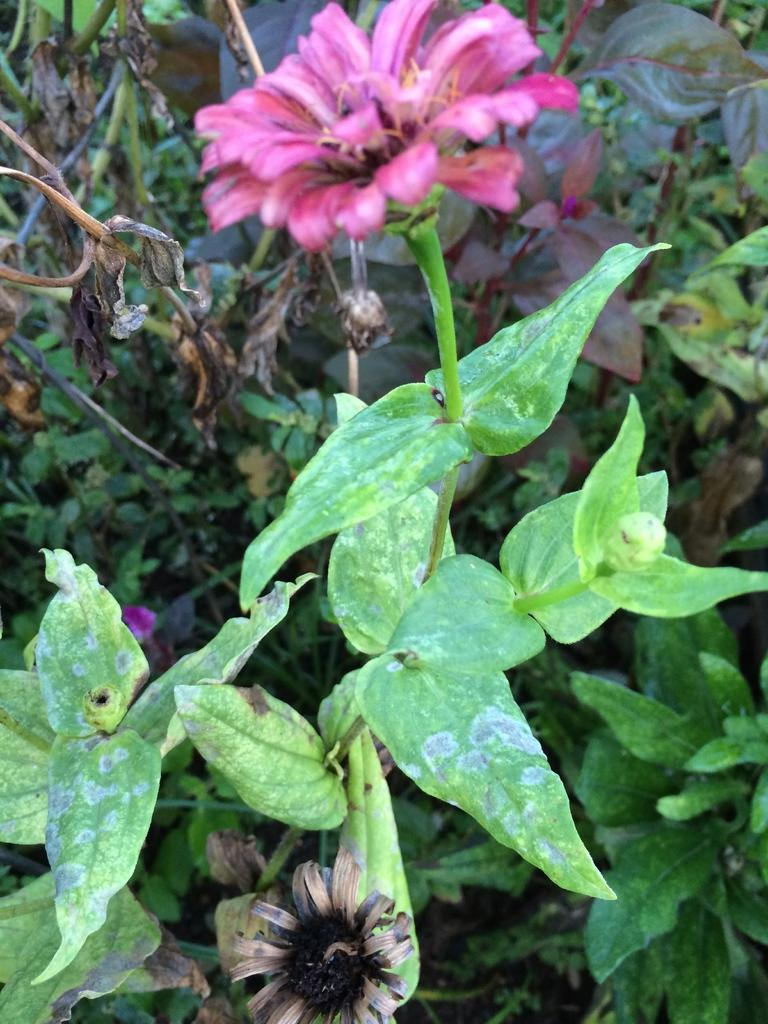What is the main subject of the image? There is a flower plant in the center of the image. Are there any other plants visible in the image? Yes, there are other plants in the background area of the image. What type of cakes can be seen in the image? There are no cakes present in the image; it features a flower plant and other plants. Can you describe the weather conditions in the image? The provided facts do not mention any weather conditions, such as fog, in the image. 